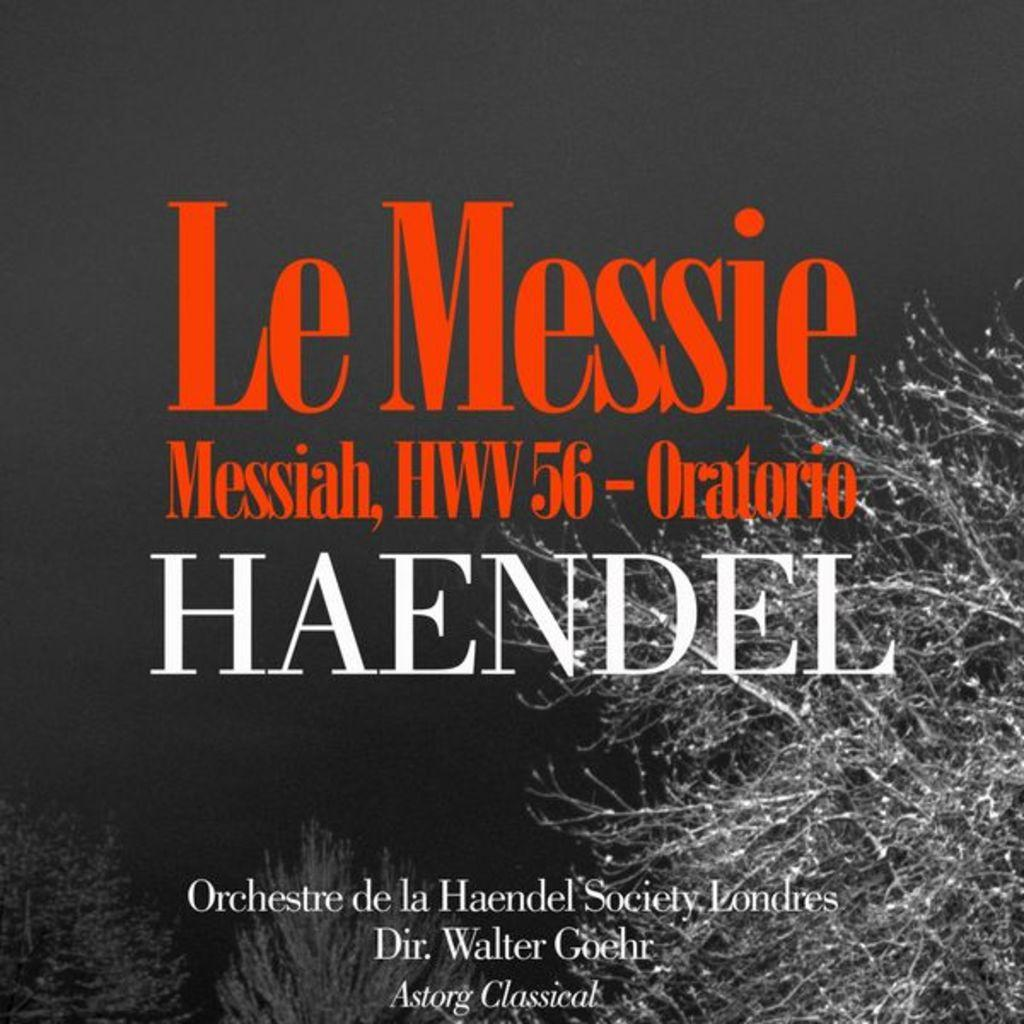<image>
Render a clear and concise summary of the photo. A classical music performance of Haendel's Messiah as directed by Walter Goehr. 